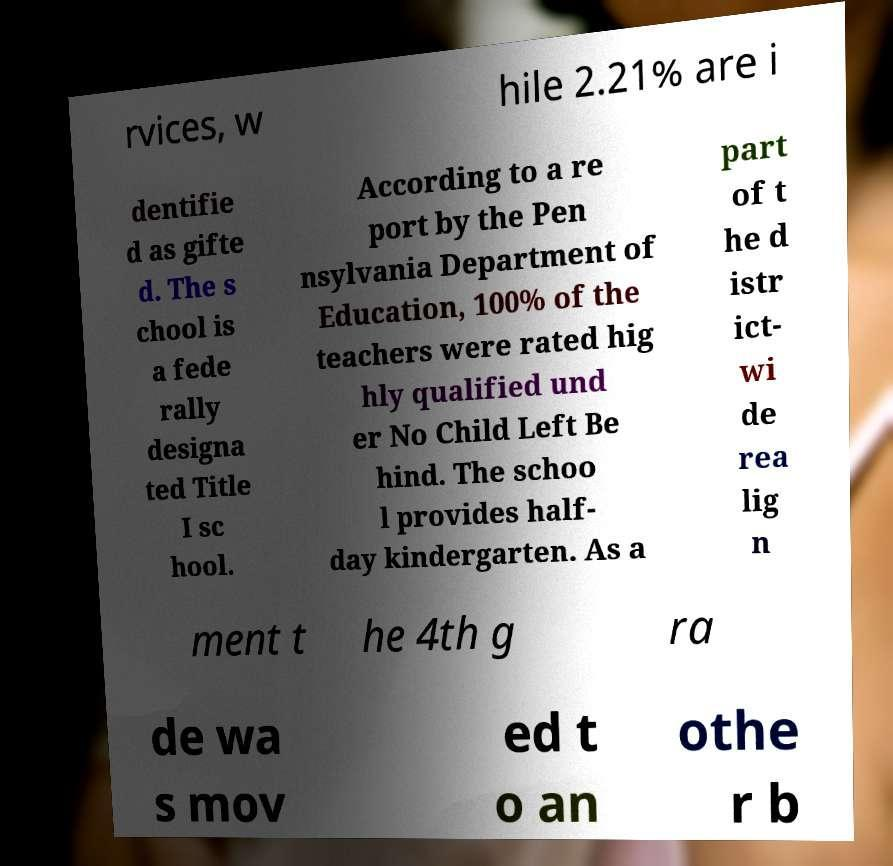Please identify and transcribe the text found in this image. rvices, w hile 2.21% are i dentifie d as gifte d. The s chool is a fede rally designa ted Title I sc hool. According to a re port by the Pen nsylvania Department of Education, 100% of the teachers were rated hig hly qualified und er No Child Left Be hind. The schoo l provides half- day kindergarten. As a part of t he d istr ict- wi de rea lig n ment t he 4th g ra de wa s mov ed t o an othe r b 